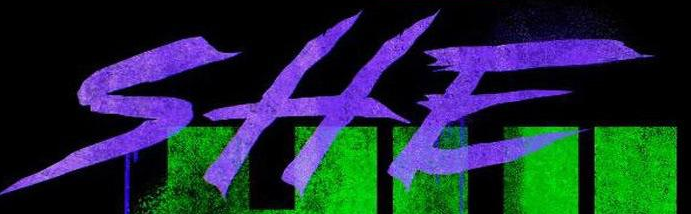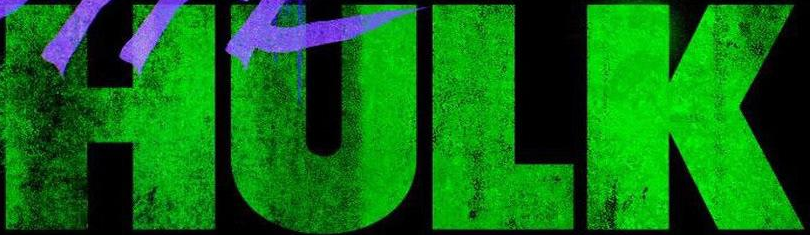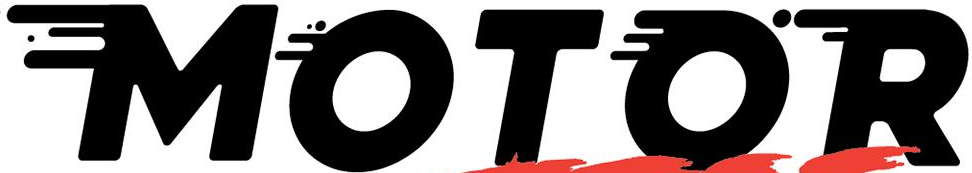Read the text from these images in sequence, separated by a semicolon. SHE; HULK; MOTOR 